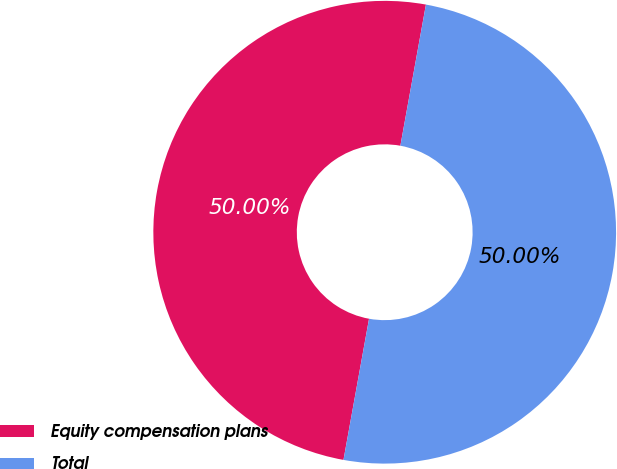Convert chart to OTSL. <chart><loc_0><loc_0><loc_500><loc_500><pie_chart><fcel>Equity compensation plans<fcel>Total<nl><fcel>50.0%<fcel>50.0%<nl></chart> 